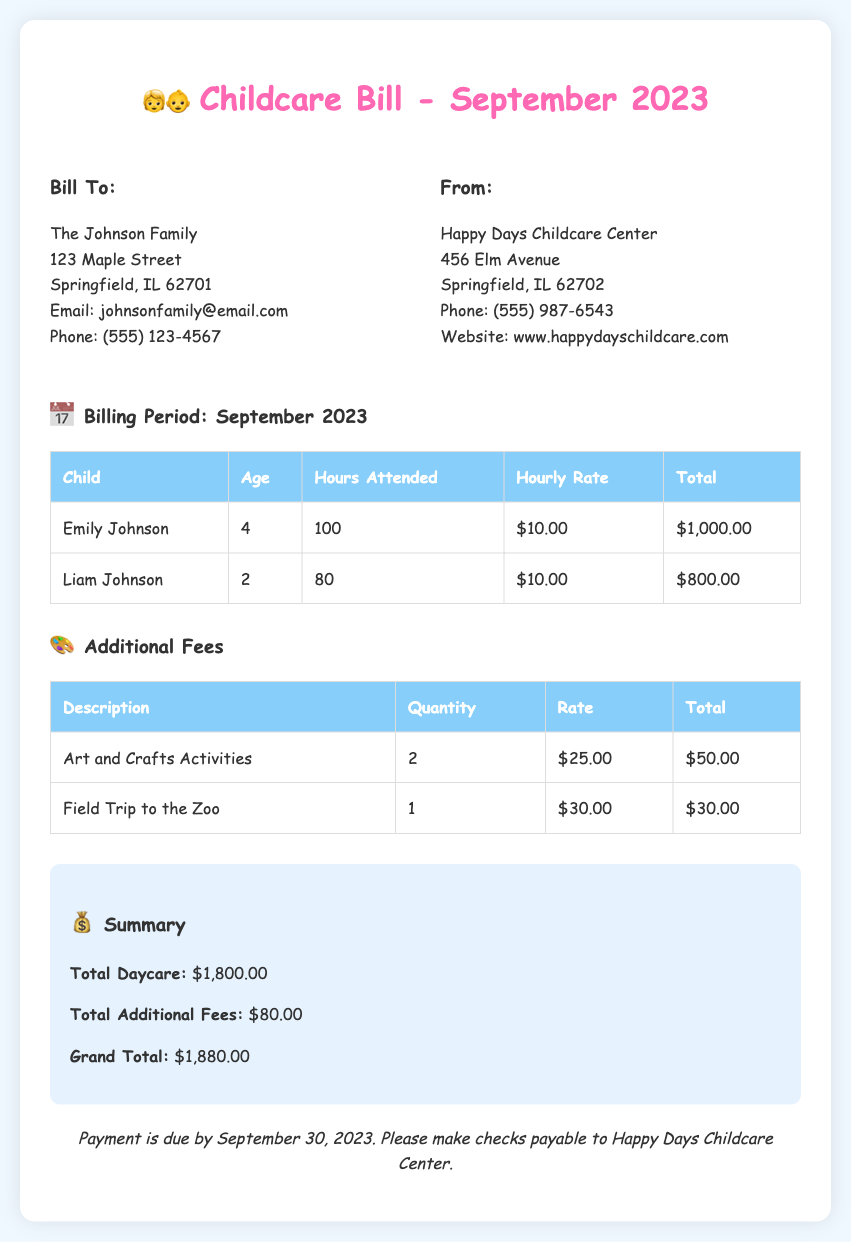what is the total daycare cost for September 2023? The total daycare cost is listed in the summary section of the document, which is $1,800.00.
Answer: $1,800.00 how many hours did Emily Johnson attend daycare? Emily Johnson's hours attended are detailed in the billing table, showing 100 hours.
Answer: 100 what is the hourly rate for both children? The hourly rate for both children is noted as $10.00 per hour.
Answer: $10.00 what is the total cost for additional activity fees? The additional fees are summarized in the document, stating a total of $80.00.
Answer: $80.00 how many children are listed in the bill? The document outlines expenses for two children: Emily and Liam Johnson.
Answer: Two what is the due date for payment? The payment terms section specifies that payment is due by September 30, 2023.
Answer: September 30, 2023 how much does the field trip to the zoo cost? The cost for the field trip to the zoo is provided in the additional fees table, which is $30.00.
Answer: $30.00 what is the total grand amount due? The grand total is clearly indicated in the summary section of the document, which is $1,880.00.
Answer: $1,880.00 